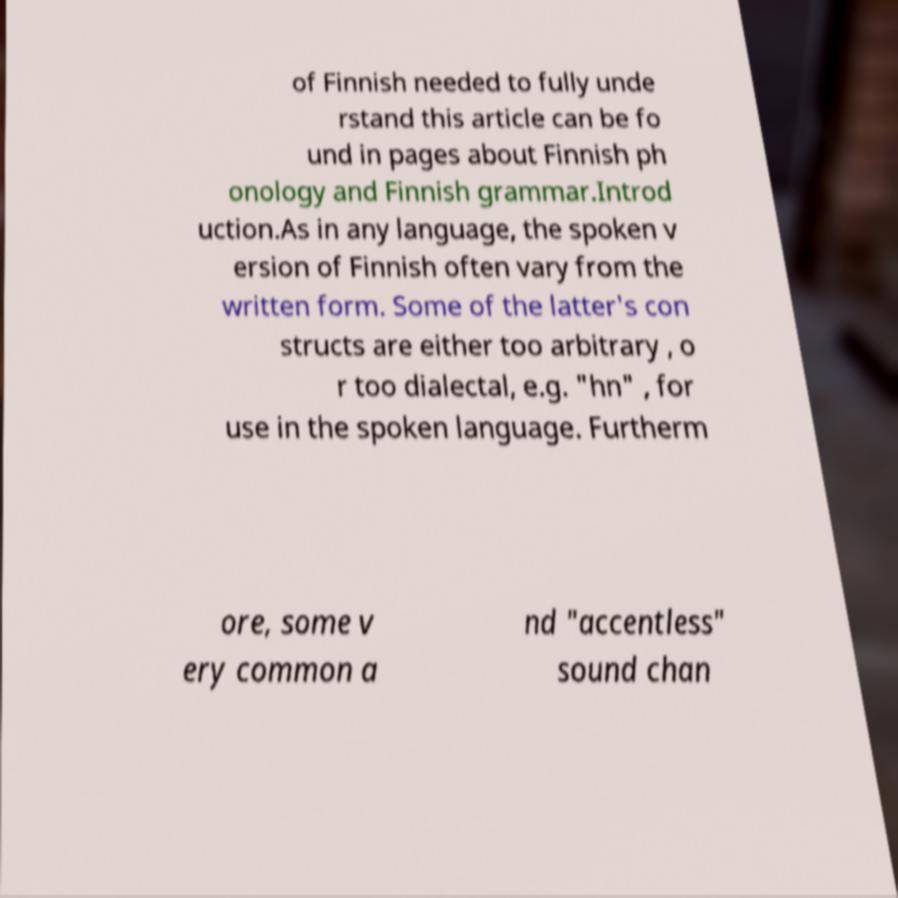I need the written content from this picture converted into text. Can you do that? of Finnish needed to fully unde rstand this article can be fo und in pages about Finnish ph onology and Finnish grammar.Introd uction.As in any language, the spoken v ersion of Finnish often vary from the written form. Some of the latter's con structs are either too arbitrary , o r too dialectal, e.g. "hn" , for use in the spoken language. Furtherm ore, some v ery common a nd "accentless" sound chan 